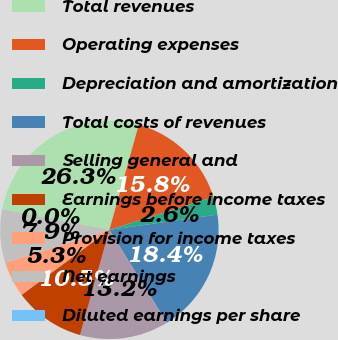<chart> <loc_0><loc_0><loc_500><loc_500><pie_chart><fcel>Total revenues<fcel>Operating expenses<fcel>Depreciation and amortization<fcel>Total costs of revenues<fcel>Selling general and<fcel>Earnings before income taxes<fcel>Provision for income taxes<fcel>Net earnings<fcel>Diluted earnings per share<nl><fcel>26.3%<fcel>15.79%<fcel>2.64%<fcel>18.42%<fcel>13.16%<fcel>10.53%<fcel>5.27%<fcel>7.9%<fcel>0.01%<nl></chart> 